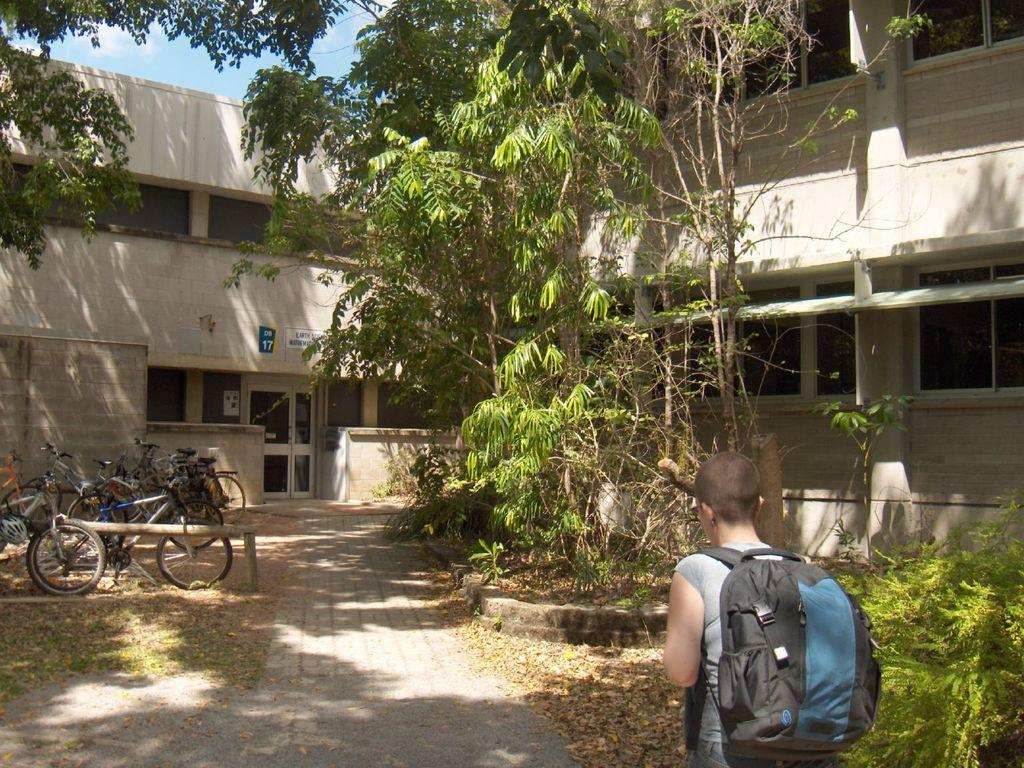What is happening in the image? There is a person in the image who is walking into a building. What is the person carrying? The person is wearing a backpack. What else can be seen in the image besides the person? There are bicycles, trees, and buildings visible in the image. What type of secretary can be seen working at the iron in the image? There is no secretary or iron present in the image. 